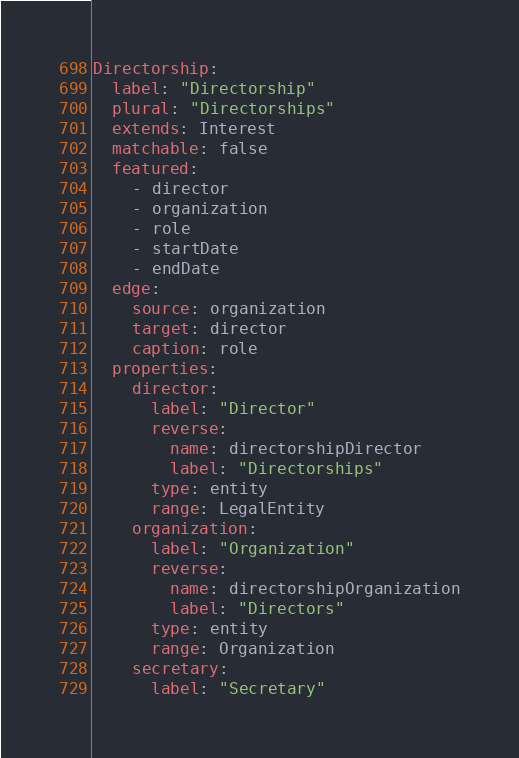Convert code to text. <code><loc_0><loc_0><loc_500><loc_500><_YAML_>Directorship:
  label: "Directorship"
  plural: "Directorships"
  extends: Interest
  matchable: false
  featured:
    - director
    - organization
    - role
    - startDate
    - endDate
  edge:
    source: organization
    target: director
    caption: role
  properties:
    director:
      label: "Director"
      reverse:
        name: directorshipDirector
        label: "Directorships"
      type: entity
      range: LegalEntity
    organization:
      label: "Organization"
      reverse:
        name: directorshipOrganization
        label: "Directors"
      type: entity
      range: Organization
    secretary:
      label: "Secretary"
</code> 